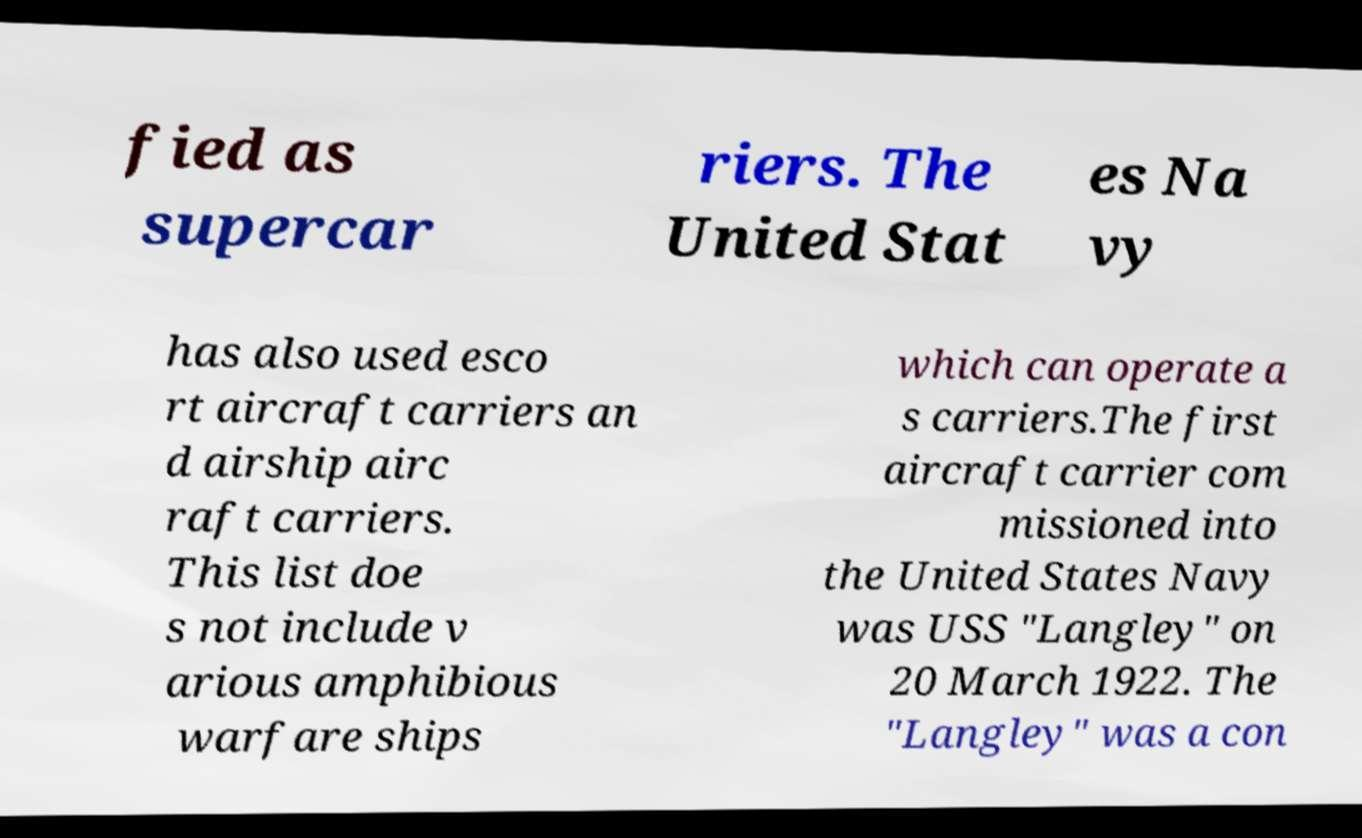Could you extract and type out the text from this image? fied as supercar riers. The United Stat es Na vy has also used esco rt aircraft carriers an d airship airc raft carriers. This list doe s not include v arious amphibious warfare ships which can operate a s carriers.The first aircraft carrier com missioned into the United States Navy was USS "Langley" on 20 March 1922. The "Langley" was a con 